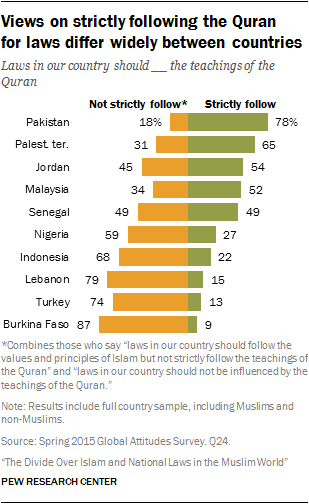Draw attention to some important aspects in this diagram. The second bar from the bottom on the right is worth 13. Burkina Faso has the largest difference between yellow and green bars when compared to other countries. 